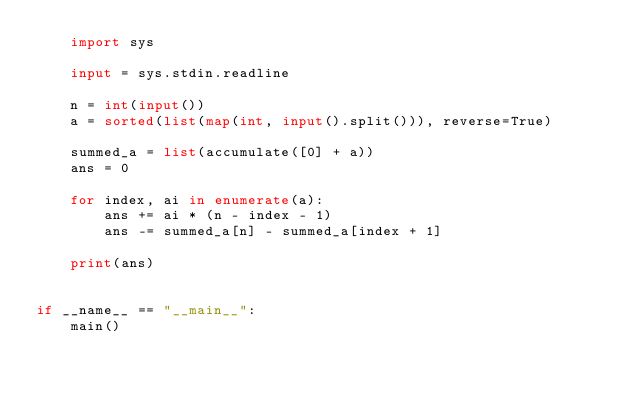Convert code to text. <code><loc_0><loc_0><loc_500><loc_500><_Python_>    import sys

    input = sys.stdin.readline

    n = int(input())
    a = sorted(list(map(int, input().split())), reverse=True)

    summed_a = list(accumulate([0] + a))
    ans = 0

    for index, ai in enumerate(a):
        ans += ai * (n - index - 1)
        ans -= summed_a[n] - summed_a[index + 1]

    print(ans)


if __name__ == "__main__":
    main()
</code> 